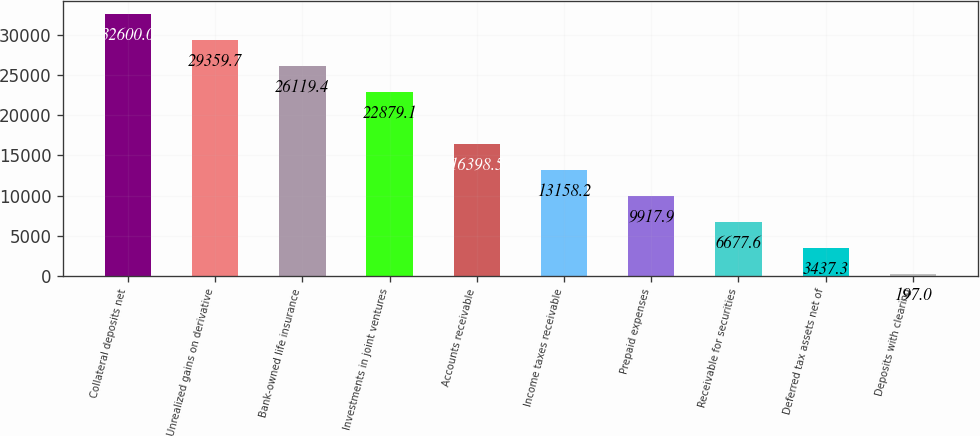<chart> <loc_0><loc_0><loc_500><loc_500><bar_chart><fcel>Collateral deposits net<fcel>Unrealized gains on derivative<fcel>Bank-owned life insurance<fcel>Investments in joint ventures<fcel>Accounts receivable<fcel>Income taxes receivable<fcel>Prepaid expenses<fcel>Receivable for securities<fcel>Deferred tax assets net of<fcel>Deposits with clearing<nl><fcel>32600<fcel>29359.7<fcel>26119.4<fcel>22879.1<fcel>16398.5<fcel>13158.2<fcel>9917.9<fcel>6677.6<fcel>3437.3<fcel>197<nl></chart> 